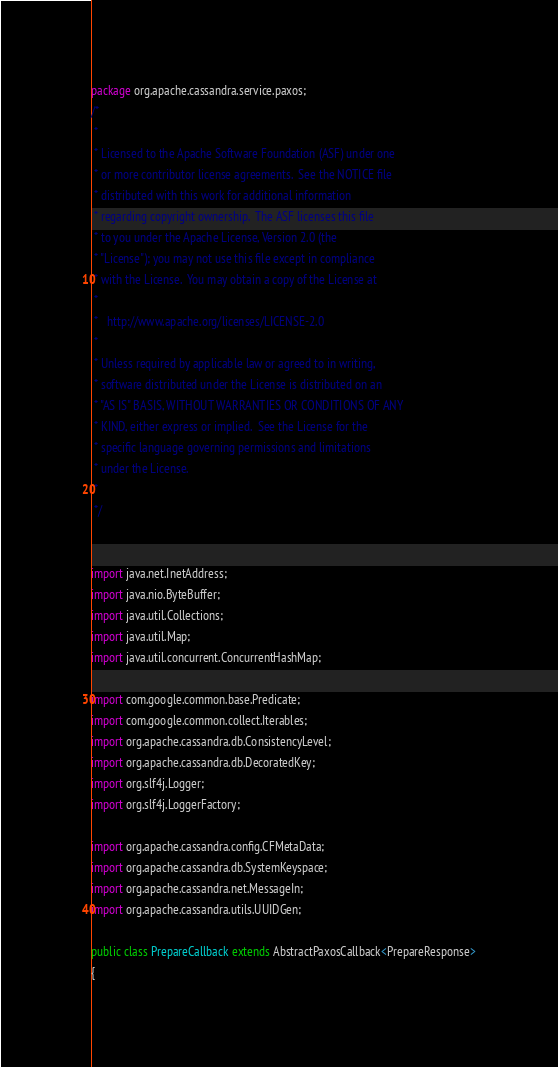<code> <loc_0><loc_0><loc_500><loc_500><_Java_>package org.apache.cassandra.service.paxos;
/*
 * 
 * Licensed to the Apache Software Foundation (ASF) under one
 * or more contributor license agreements.  See the NOTICE file
 * distributed with this work for additional information
 * regarding copyright ownership.  The ASF licenses this file
 * to you under the Apache License, Version 2.0 (the
 * "License"); you may not use this file except in compliance
 * with the License.  You may obtain a copy of the License at
 * 
 *   http://www.apache.org/licenses/LICENSE-2.0
 * 
 * Unless required by applicable law or agreed to in writing,
 * software distributed under the License is distributed on an
 * "AS IS" BASIS, WITHOUT WARRANTIES OR CONDITIONS OF ANY
 * KIND, either express or implied.  See the License for the
 * specific language governing permissions and limitations
 * under the License.
 * 
 */


import java.net.InetAddress;
import java.nio.ByteBuffer;
import java.util.Collections;
import java.util.Map;
import java.util.concurrent.ConcurrentHashMap;

import com.google.common.base.Predicate;
import com.google.common.collect.Iterables;
import org.apache.cassandra.db.ConsistencyLevel;
import org.apache.cassandra.db.DecoratedKey;
import org.slf4j.Logger;
import org.slf4j.LoggerFactory;

import org.apache.cassandra.config.CFMetaData;
import org.apache.cassandra.db.SystemKeyspace;
import org.apache.cassandra.net.MessageIn;
import org.apache.cassandra.utils.UUIDGen;

public class PrepareCallback extends AbstractPaxosCallback<PrepareResponse>
{</code> 